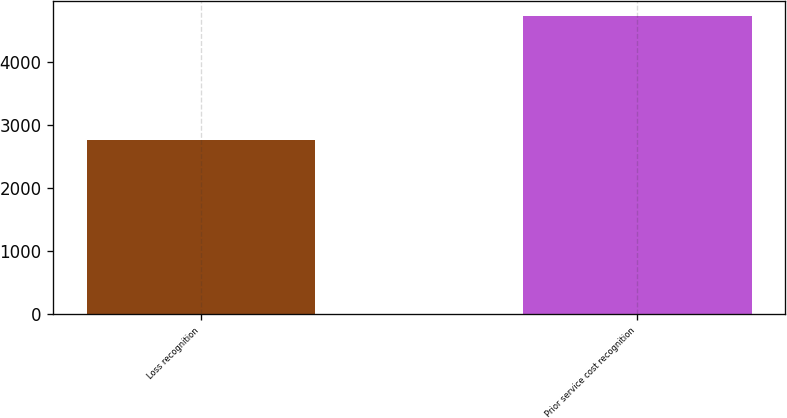<chart> <loc_0><loc_0><loc_500><loc_500><bar_chart><fcel>Loss recognition<fcel>Prior service cost recognition<nl><fcel>2763<fcel>4719<nl></chart> 